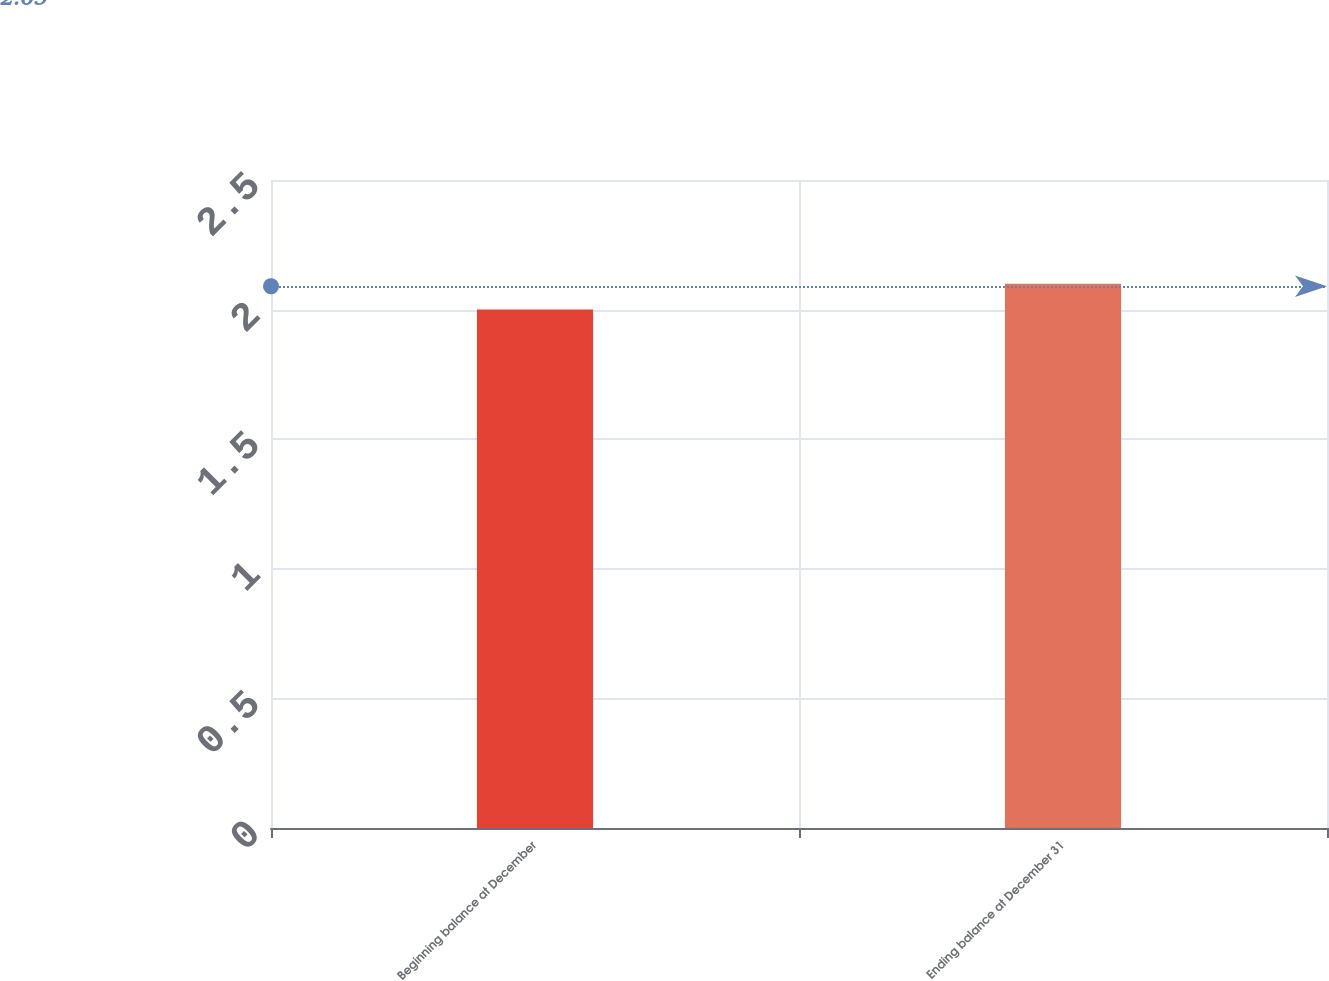<chart> <loc_0><loc_0><loc_500><loc_500><bar_chart><fcel>Beginning balance at December<fcel>Ending balance at December 31<nl><fcel>2<fcel>2.1<nl></chart> 